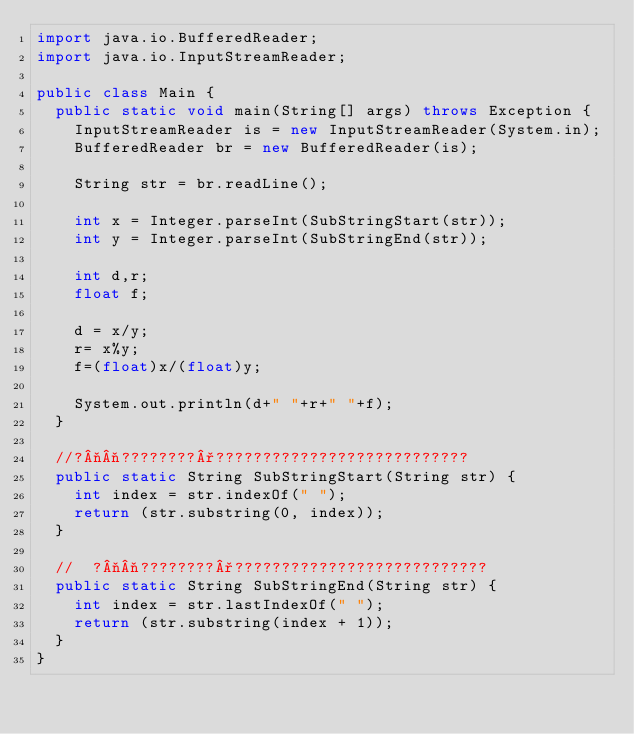Convert code to text. <code><loc_0><loc_0><loc_500><loc_500><_Java_>import java.io.BufferedReader;
import java.io.InputStreamReader;

public class Main {
	public static void main(String[] args) throws Exception {
		InputStreamReader is = new InputStreamReader(System.in);
		BufferedReader br = new BufferedReader(is);

		String str = br.readLine();

		int x = Integer.parseInt(SubStringStart(str));
		int y = Integer.parseInt(SubStringEnd(str));

		int d,r;
		float f;

		d = x/y;
		r= x%y;
		f=(float)x/(float)y;

		System.out.println(d+" "+r+" "+f);
	}

	//?¬¬????????°???????????????????????????
	public static String SubStringStart(String str) {
		int index = str.indexOf(" ");
		return (str.substring(0, index));
	}

	//	?¬¬????????°???????????????????????????
	public static String SubStringEnd(String str) {
		int index = str.lastIndexOf(" ");
		return (str.substring(index + 1));
	}
}</code> 